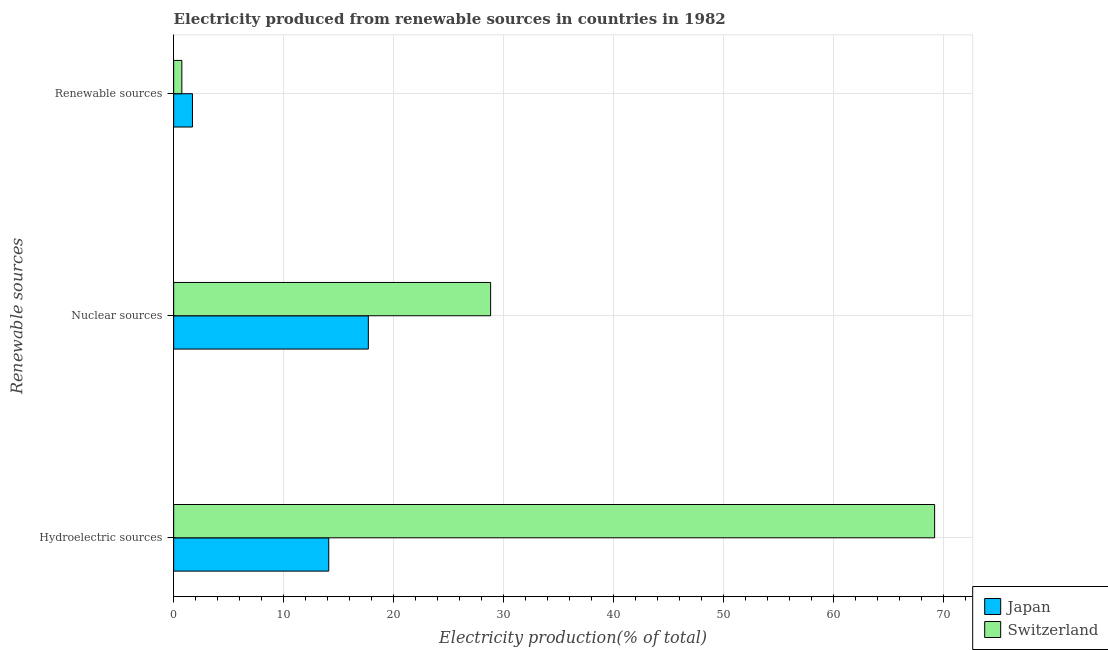Are the number of bars per tick equal to the number of legend labels?
Make the answer very short. Yes. What is the label of the 3rd group of bars from the top?
Your answer should be very brief. Hydroelectric sources. What is the percentage of electricity produced by renewable sources in Japan?
Keep it short and to the point. 1.71. Across all countries, what is the maximum percentage of electricity produced by nuclear sources?
Make the answer very short. 28.82. Across all countries, what is the minimum percentage of electricity produced by renewable sources?
Your answer should be compact. 0.74. In which country was the percentage of electricity produced by nuclear sources maximum?
Provide a short and direct response. Switzerland. In which country was the percentage of electricity produced by hydroelectric sources minimum?
Provide a short and direct response. Japan. What is the total percentage of electricity produced by nuclear sources in the graph?
Offer a very short reply. 46.52. What is the difference between the percentage of electricity produced by hydroelectric sources in Japan and that in Switzerland?
Offer a terse response. -55.09. What is the difference between the percentage of electricity produced by nuclear sources in Switzerland and the percentage of electricity produced by hydroelectric sources in Japan?
Offer a terse response. 14.72. What is the average percentage of electricity produced by renewable sources per country?
Keep it short and to the point. 1.23. What is the difference between the percentage of electricity produced by hydroelectric sources and percentage of electricity produced by nuclear sources in Japan?
Keep it short and to the point. -3.6. In how many countries, is the percentage of electricity produced by nuclear sources greater than 18 %?
Provide a short and direct response. 1. What is the ratio of the percentage of electricity produced by nuclear sources in Switzerland to that in Japan?
Make the answer very short. 1.63. Is the percentage of electricity produced by hydroelectric sources in Japan less than that in Switzerland?
Offer a very short reply. Yes. What is the difference between the highest and the second highest percentage of electricity produced by renewable sources?
Offer a very short reply. 0.97. What is the difference between the highest and the lowest percentage of electricity produced by renewable sources?
Make the answer very short. 0.97. Is the sum of the percentage of electricity produced by renewable sources in Japan and Switzerland greater than the maximum percentage of electricity produced by hydroelectric sources across all countries?
Keep it short and to the point. No. What does the 1st bar from the top in Nuclear sources represents?
Provide a succinct answer. Switzerland. What does the 2nd bar from the bottom in Hydroelectric sources represents?
Offer a very short reply. Switzerland. What is the difference between two consecutive major ticks on the X-axis?
Offer a very short reply. 10. Where does the legend appear in the graph?
Make the answer very short. Bottom right. How many legend labels are there?
Keep it short and to the point. 2. How are the legend labels stacked?
Provide a short and direct response. Vertical. What is the title of the graph?
Make the answer very short. Electricity produced from renewable sources in countries in 1982. What is the label or title of the X-axis?
Ensure brevity in your answer.  Electricity production(% of total). What is the label or title of the Y-axis?
Ensure brevity in your answer.  Renewable sources. What is the Electricity production(% of total) of Japan in Hydroelectric sources?
Offer a terse response. 14.1. What is the Electricity production(% of total) in Switzerland in Hydroelectric sources?
Ensure brevity in your answer.  69.2. What is the Electricity production(% of total) in Japan in Nuclear sources?
Give a very brief answer. 17.7. What is the Electricity production(% of total) in Switzerland in Nuclear sources?
Your response must be concise. 28.82. What is the Electricity production(% of total) of Japan in Renewable sources?
Give a very brief answer. 1.71. What is the Electricity production(% of total) in Switzerland in Renewable sources?
Ensure brevity in your answer.  0.74. Across all Renewable sources, what is the maximum Electricity production(% of total) in Japan?
Give a very brief answer. 17.7. Across all Renewable sources, what is the maximum Electricity production(% of total) in Switzerland?
Keep it short and to the point. 69.2. Across all Renewable sources, what is the minimum Electricity production(% of total) in Japan?
Your answer should be compact. 1.71. Across all Renewable sources, what is the minimum Electricity production(% of total) in Switzerland?
Make the answer very short. 0.74. What is the total Electricity production(% of total) in Japan in the graph?
Offer a very short reply. 33.51. What is the total Electricity production(% of total) of Switzerland in the graph?
Provide a succinct answer. 98.76. What is the difference between the Electricity production(% of total) of Japan in Hydroelectric sources and that in Nuclear sources?
Give a very brief answer. -3.6. What is the difference between the Electricity production(% of total) of Switzerland in Hydroelectric sources and that in Nuclear sources?
Provide a succinct answer. 40.37. What is the difference between the Electricity production(% of total) in Japan in Hydroelectric sources and that in Renewable sources?
Provide a succinct answer. 12.39. What is the difference between the Electricity production(% of total) in Switzerland in Hydroelectric sources and that in Renewable sources?
Your response must be concise. 68.45. What is the difference between the Electricity production(% of total) in Japan in Nuclear sources and that in Renewable sources?
Ensure brevity in your answer.  15.99. What is the difference between the Electricity production(% of total) in Switzerland in Nuclear sources and that in Renewable sources?
Your answer should be compact. 28.08. What is the difference between the Electricity production(% of total) of Japan in Hydroelectric sources and the Electricity production(% of total) of Switzerland in Nuclear sources?
Your answer should be compact. -14.72. What is the difference between the Electricity production(% of total) of Japan in Hydroelectric sources and the Electricity production(% of total) of Switzerland in Renewable sources?
Make the answer very short. 13.36. What is the difference between the Electricity production(% of total) in Japan in Nuclear sources and the Electricity production(% of total) in Switzerland in Renewable sources?
Provide a succinct answer. 16.96. What is the average Electricity production(% of total) in Japan per Renewable sources?
Your answer should be compact. 11.17. What is the average Electricity production(% of total) of Switzerland per Renewable sources?
Provide a succinct answer. 32.92. What is the difference between the Electricity production(% of total) in Japan and Electricity production(% of total) in Switzerland in Hydroelectric sources?
Provide a succinct answer. -55.09. What is the difference between the Electricity production(% of total) in Japan and Electricity production(% of total) in Switzerland in Nuclear sources?
Keep it short and to the point. -11.12. What is the difference between the Electricity production(% of total) in Japan and Electricity production(% of total) in Switzerland in Renewable sources?
Make the answer very short. 0.97. What is the ratio of the Electricity production(% of total) in Japan in Hydroelectric sources to that in Nuclear sources?
Keep it short and to the point. 0.8. What is the ratio of the Electricity production(% of total) of Switzerland in Hydroelectric sources to that in Nuclear sources?
Provide a short and direct response. 2.4. What is the ratio of the Electricity production(% of total) of Japan in Hydroelectric sources to that in Renewable sources?
Provide a succinct answer. 8.25. What is the ratio of the Electricity production(% of total) of Switzerland in Hydroelectric sources to that in Renewable sources?
Provide a succinct answer. 93.16. What is the ratio of the Electricity production(% of total) of Japan in Nuclear sources to that in Renewable sources?
Your response must be concise. 10.35. What is the ratio of the Electricity production(% of total) in Switzerland in Nuclear sources to that in Renewable sources?
Make the answer very short. 38.8. What is the difference between the highest and the second highest Electricity production(% of total) in Japan?
Give a very brief answer. 3.6. What is the difference between the highest and the second highest Electricity production(% of total) in Switzerland?
Your response must be concise. 40.37. What is the difference between the highest and the lowest Electricity production(% of total) of Japan?
Provide a short and direct response. 15.99. What is the difference between the highest and the lowest Electricity production(% of total) in Switzerland?
Offer a terse response. 68.45. 